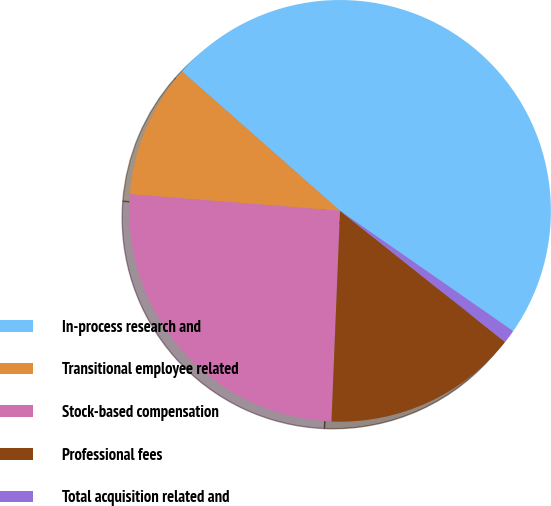Convert chart. <chart><loc_0><loc_0><loc_500><loc_500><pie_chart><fcel>In-process research and<fcel>Transitional employee related<fcel>Stock-based compensation<fcel>Professional fees<fcel>Total acquisition related and<nl><fcel>48.16%<fcel>10.25%<fcel>25.61%<fcel>14.96%<fcel>1.02%<nl></chart> 